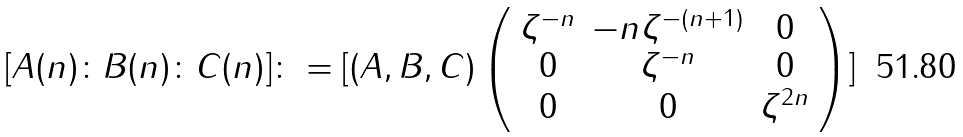Convert formula to latex. <formula><loc_0><loc_0><loc_500><loc_500>[ A ( n ) \colon B ( n ) \colon C ( n ) ] \colon = [ ( A , B , C ) \left ( \begin{array} { c c c } \zeta ^ { - n } & - n \zeta ^ { - ( n + 1 ) } & 0 \\ 0 & \zeta ^ { - n } & 0 \\ 0 & 0 & \zeta ^ { 2 n } \end{array} \right ) ]</formula> 